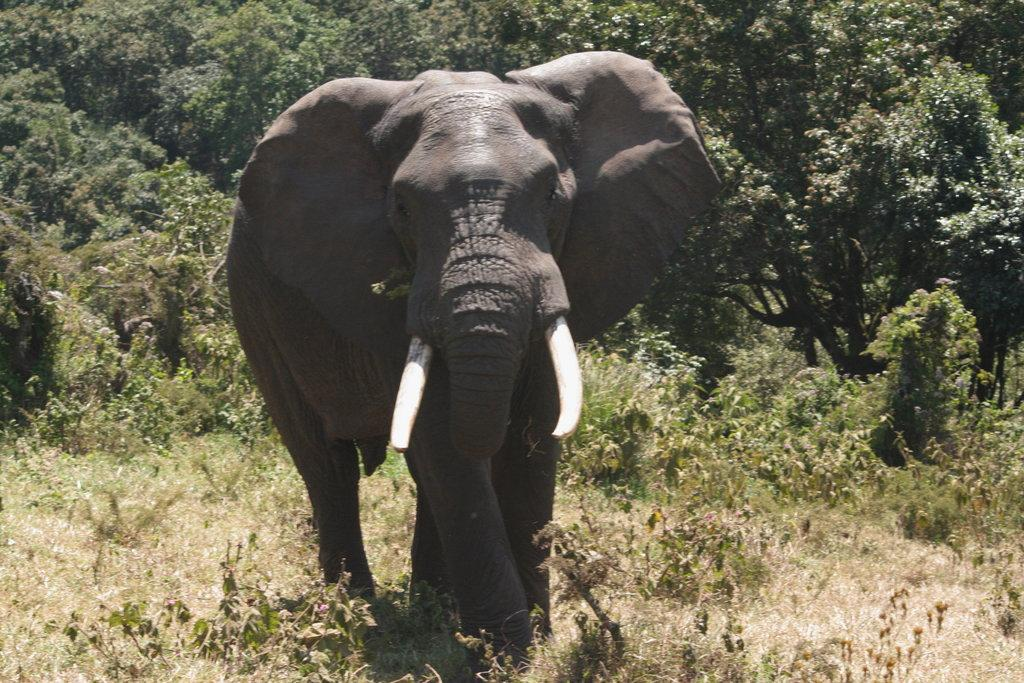What animal is present in the image? There is an elephant in the image. What type of vegetation can be seen in the image? There are trees in the image. How many tables can be seen in the image? There are no tables present in the image. Can you tell me how many times the elephant sneezes in the image? The image does not depict the elephant sneezing, so it is not possible to determine how many times it sneezes. 